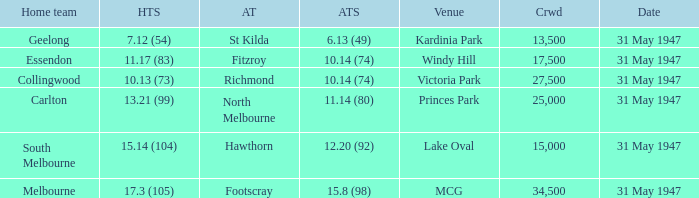What is the home team's score at mcg? 17.3 (105). 